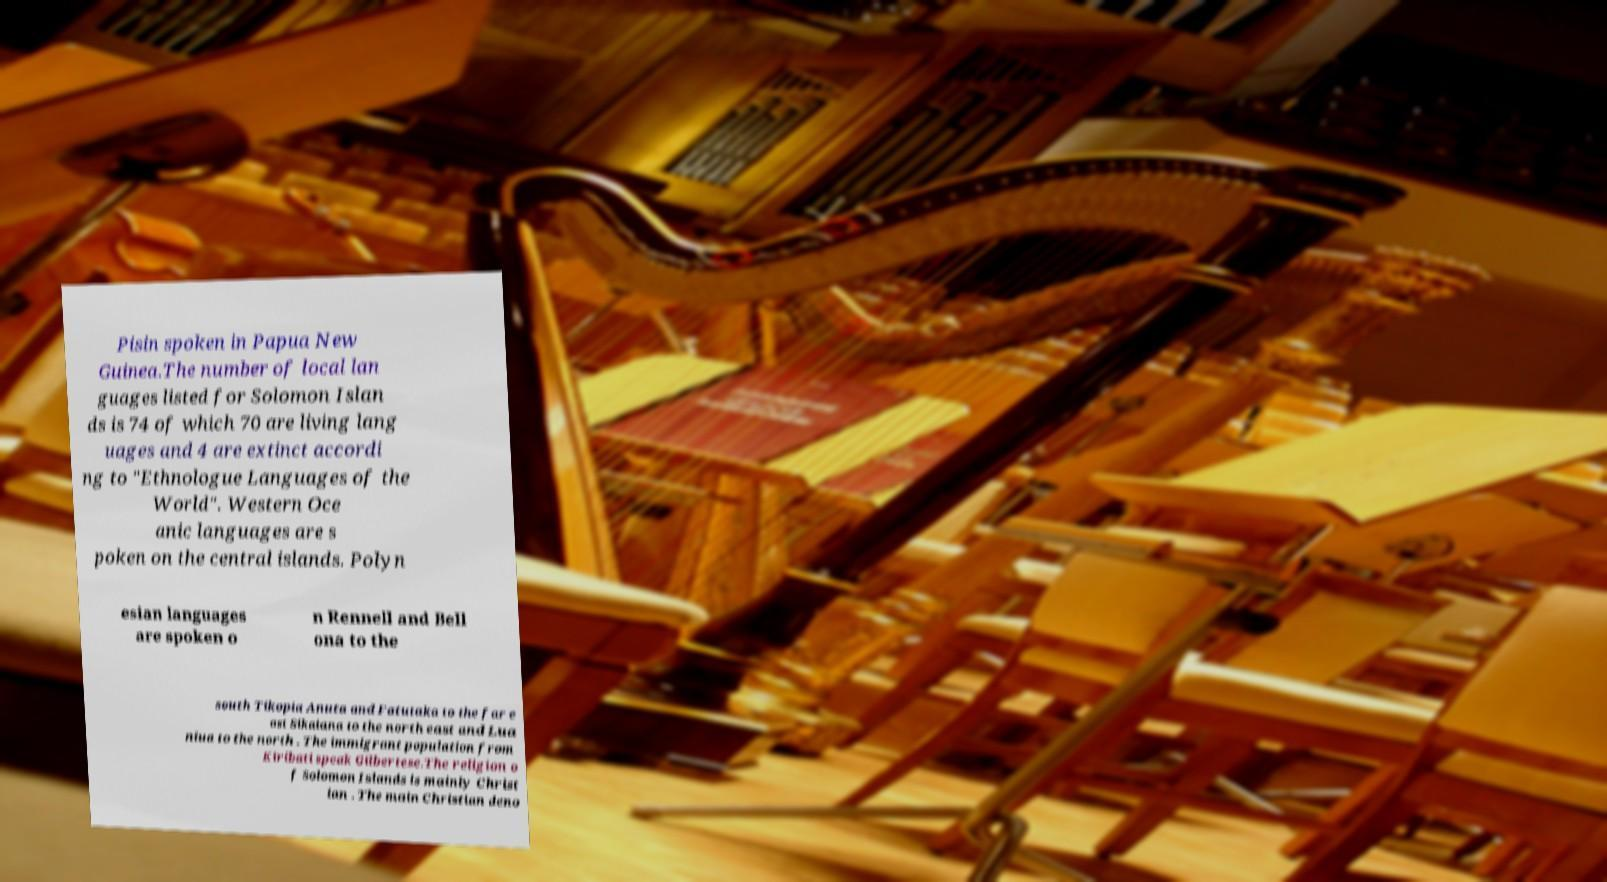There's text embedded in this image that I need extracted. Can you transcribe it verbatim? Pisin spoken in Papua New Guinea.The number of local lan guages listed for Solomon Islan ds is 74 of which 70 are living lang uages and 4 are extinct accordi ng to "Ethnologue Languages of the World". Western Oce anic languages are s poken on the central islands. Polyn esian languages are spoken o n Rennell and Bell ona to the south Tikopia Anuta and Fatutaka to the far e ast Sikaiana to the north east and Lua niua to the north . The immigrant population from Kiribati speak Gilbertese.The religion o f Solomon Islands is mainly Christ ian . The main Christian deno 